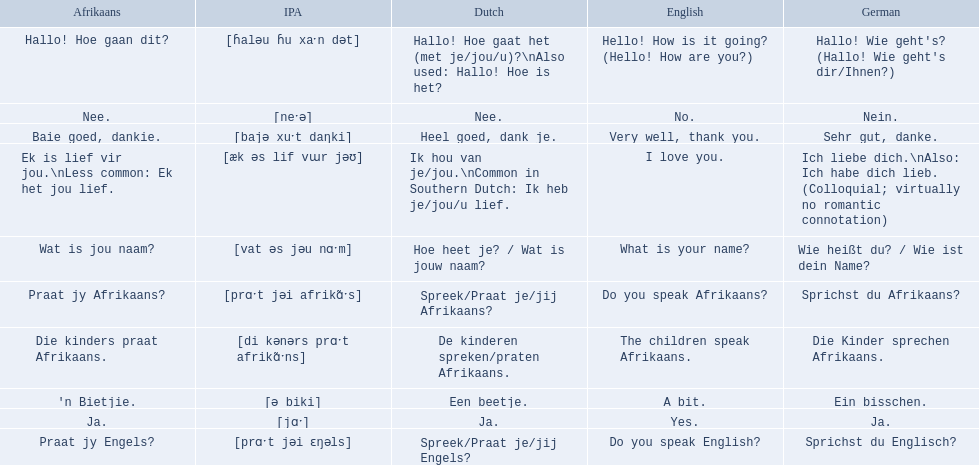What are all of the afrikaans phrases shown in the table? Hallo! Hoe gaan dit?, Baie goed, dankie., Praat jy Afrikaans?, Praat jy Engels?, Ja., Nee., 'n Bietjie., Wat is jou naam?, Die kinders praat Afrikaans., Ek is lief vir jou.\nLess common: Ek het jou lief. Of those, which translates into english as do you speak afrikaans?? Praat jy Afrikaans?. 